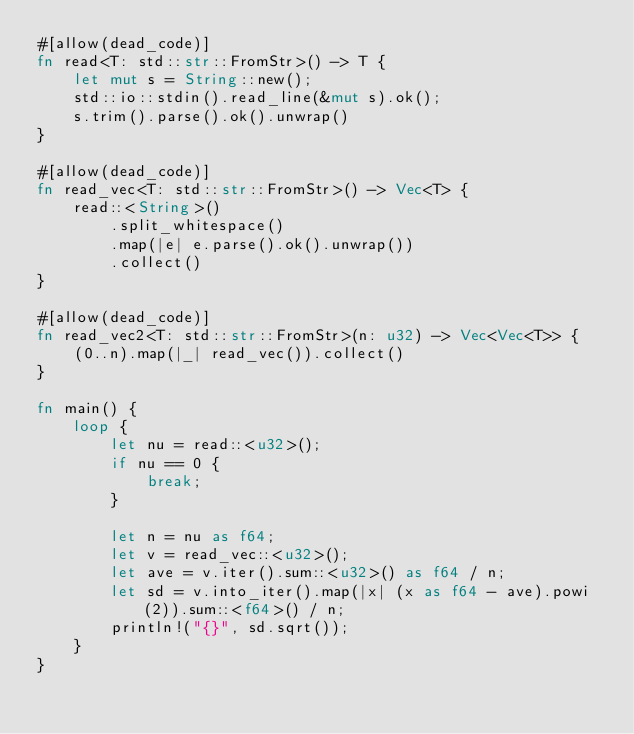<code> <loc_0><loc_0><loc_500><loc_500><_Rust_>#[allow(dead_code)]
fn read<T: std::str::FromStr>() -> T {
    let mut s = String::new();
    std::io::stdin().read_line(&mut s).ok();
    s.trim().parse().ok().unwrap()
}

#[allow(dead_code)]
fn read_vec<T: std::str::FromStr>() -> Vec<T> {
    read::<String>()
        .split_whitespace()
        .map(|e| e.parse().ok().unwrap())
        .collect()
}

#[allow(dead_code)]
fn read_vec2<T: std::str::FromStr>(n: u32) -> Vec<Vec<T>> {
    (0..n).map(|_| read_vec()).collect()
}

fn main() {
    loop {
        let nu = read::<u32>();
        if nu == 0 {
            break;
        }

        let n = nu as f64;
        let v = read_vec::<u32>();
        let ave = v.iter().sum::<u32>() as f64 / n;
        let sd = v.into_iter().map(|x| (x as f64 - ave).powi(2)).sum::<f64>() / n;
        println!("{}", sd.sqrt());
    }
}

</code> 